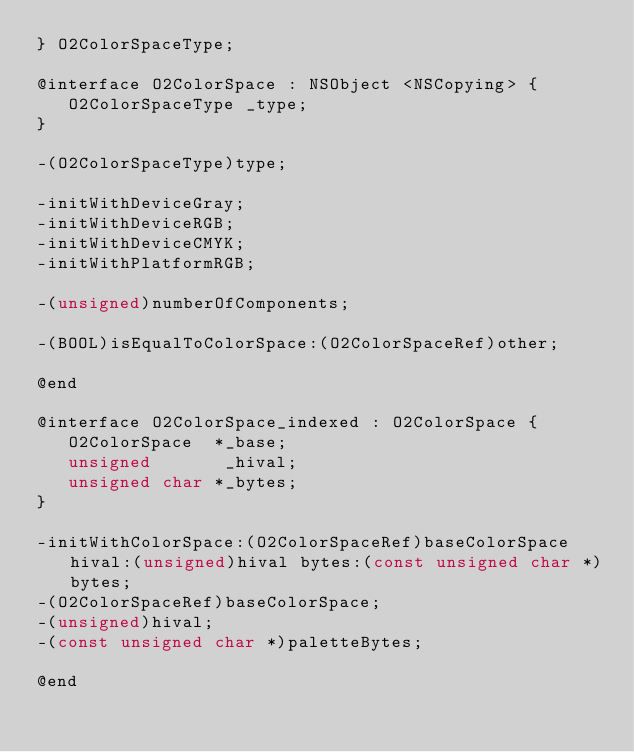Convert code to text. <code><loc_0><loc_0><loc_500><loc_500><_C_>} O2ColorSpaceType;

@interface O2ColorSpace : NSObject <NSCopying> {
   O2ColorSpaceType _type;
}

-(O2ColorSpaceType)type;

-initWithDeviceGray;
-initWithDeviceRGB;
-initWithDeviceCMYK;
-initWithPlatformRGB;

-(unsigned)numberOfComponents;

-(BOOL)isEqualToColorSpace:(O2ColorSpaceRef)other;

@end

@interface O2ColorSpace_indexed : O2ColorSpace {
   O2ColorSpace  *_base;
   unsigned       _hival;
   unsigned char *_bytes;
}

-initWithColorSpace:(O2ColorSpaceRef)baseColorSpace hival:(unsigned)hival bytes:(const unsigned char *)bytes;
-(O2ColorSpaceRef)baseColorSpace;
-(unsigned)hival;
-(const unsigned char *)paletteBytes;

@end
</code> 